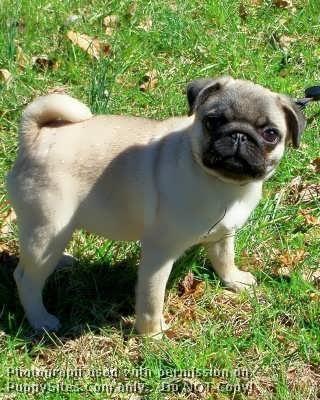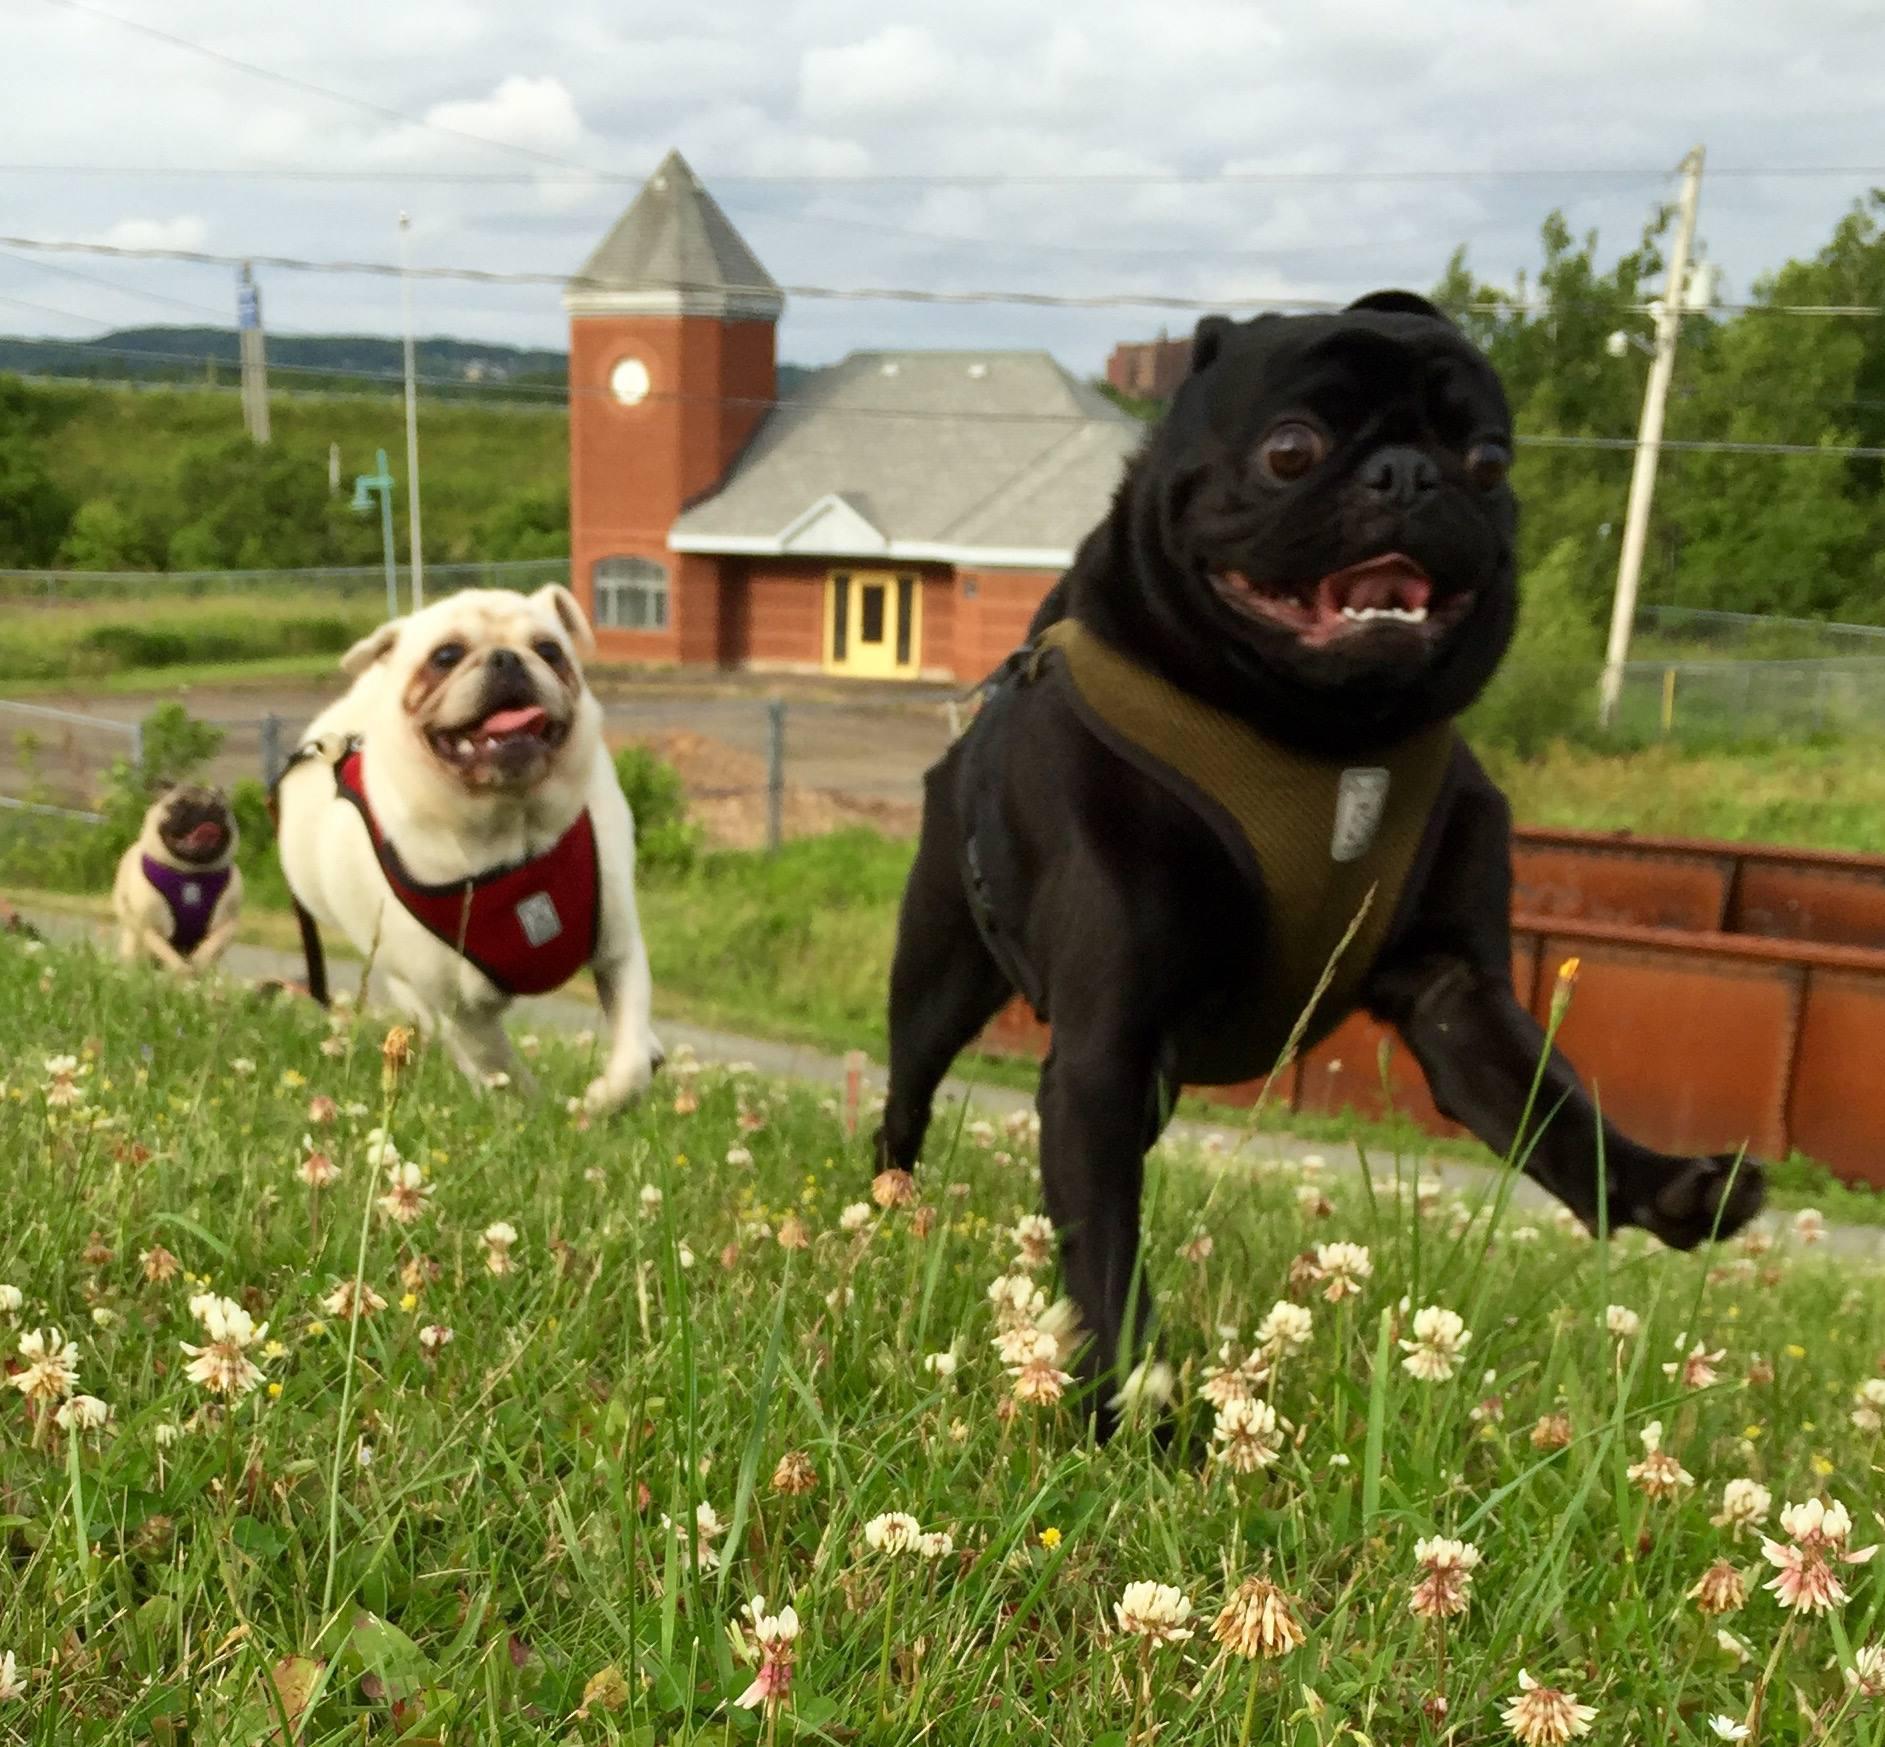The first image is the image on the left, the second image is the image on the right. Considering the images on both sides, is "A dog is running." valid? Answer yes or no. Yes. The first image is the image on the left, the second image is the image on the right. For the images shown, is this caption "The right image contains at least three dogs." true? Answer yes or no. Yes. 